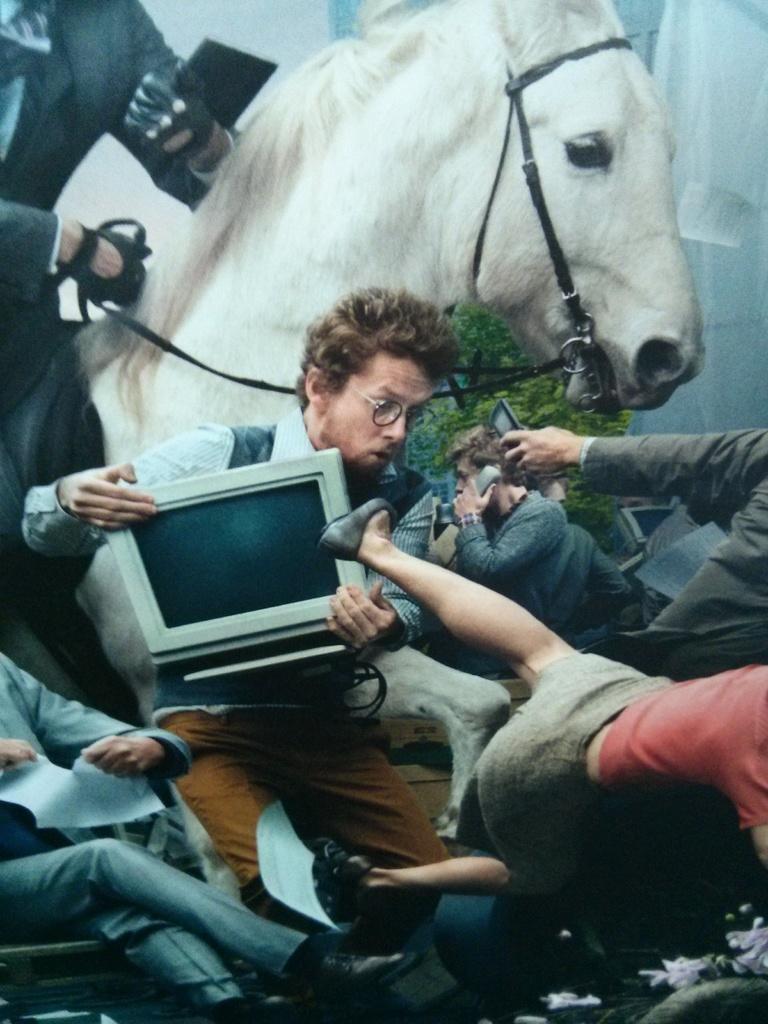Please provide a concise description of this image. In this image I can see people, horse and plant. Among them one person is sitting on a chair and other people are holding objects. 